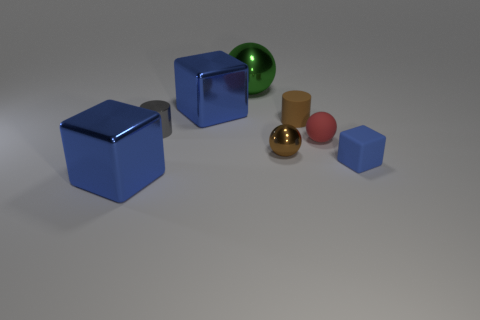How many blue blocks must be subtracted to get 1 blue blocks? 2 Subtract all blue metal cubes. How many cubes are left? 1 Subtract all cylinders. How many objects are left? 6 Add 2 brown things. How many objects exist? 10 Subtract all blocks. Subtract all big balls. How many objects are left? 4 Add 2 red rubber things. How many red rubber things are left? 3 Add 8 large green spheres. How many large green spheres exist? 9 Subtract 1 green balls. How many objects are left? 7 